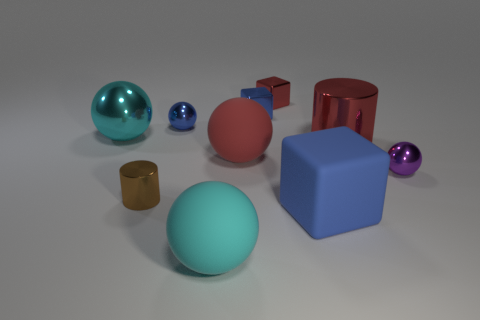Subtract all blue spheres. How many spheres are left? 4 Subtract all big red spheres. How many spheres are left? 4 Subtract all gray balls. Subtract all yellow cylinders. How many balls are left? 5 Subtract all blocks. How many objects are left? 7 Add 8 blue shiny objects. How many blue shiny objects exist? 10 Subtract 0 yellow cylinders. How many objects are left? 10 Subtract all big cylinders. Subtract all small purple metal spheres. How many objects are left? 8 Add 9 rubber cubes. How many rubber cubes are left? 10 